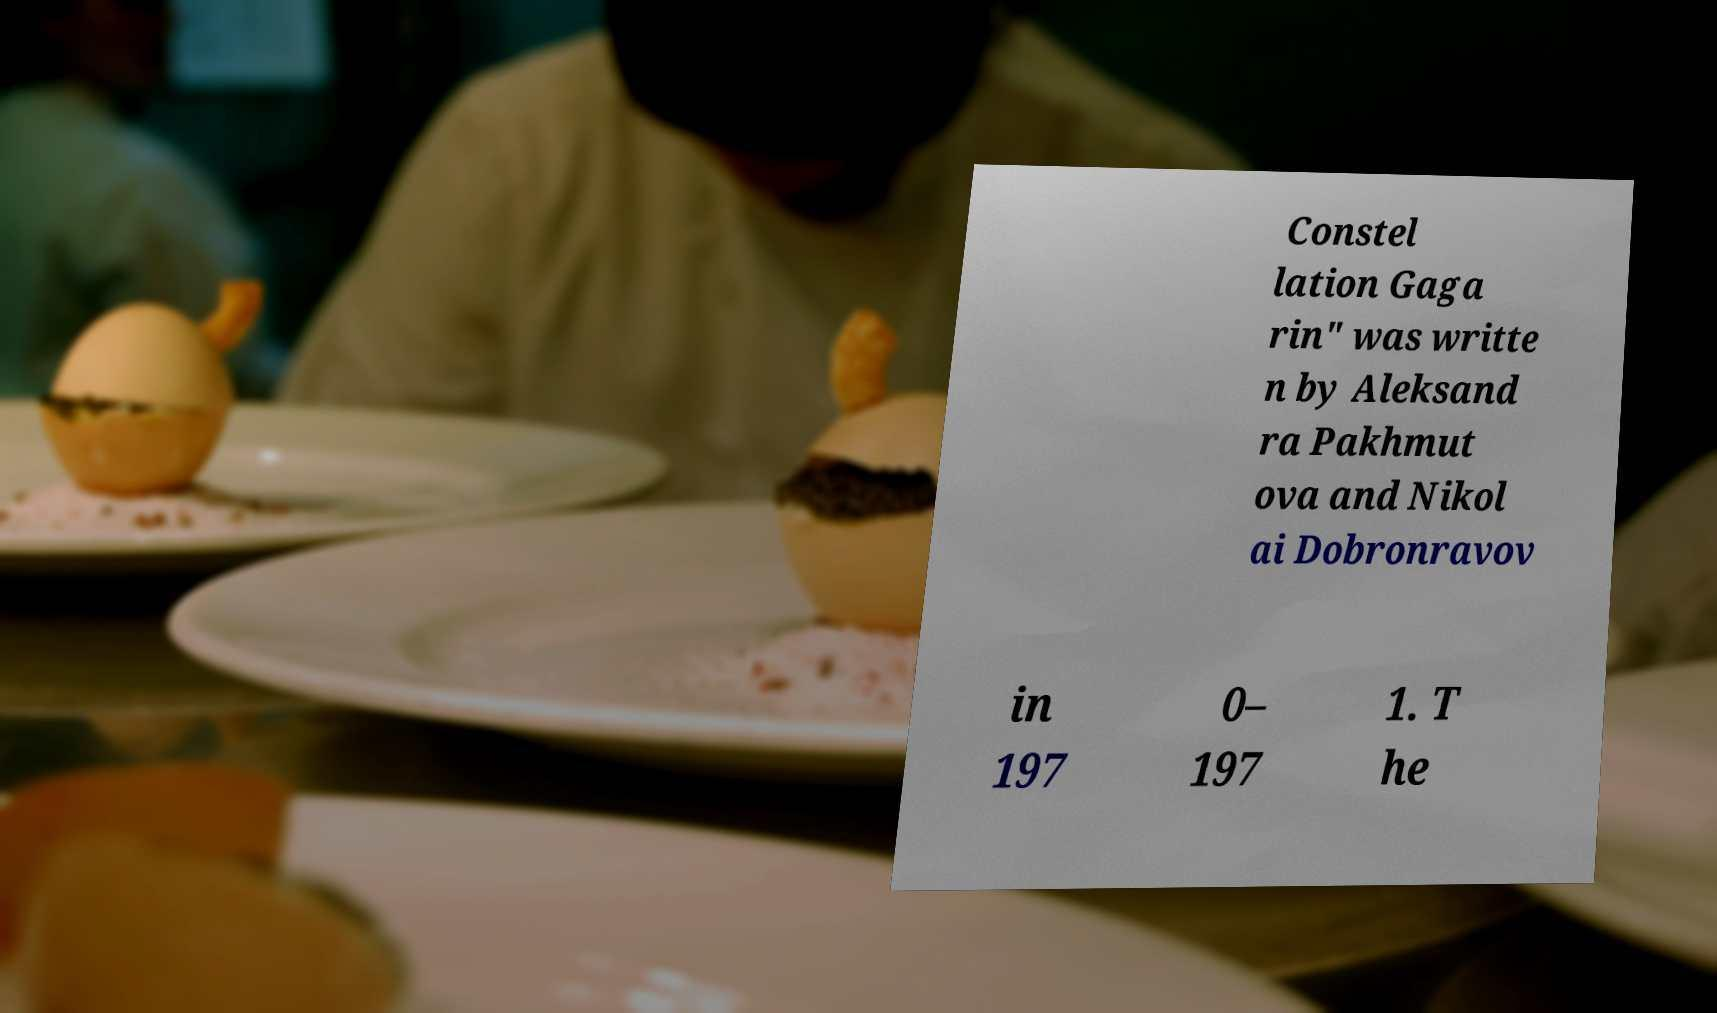Could you extract and type out the text from this image? Constel lation Gaga rin" was writte n by Aleksand ra Pakhmut ova and Nikol ai Dobronravov in 197 0– 197 1. T he 